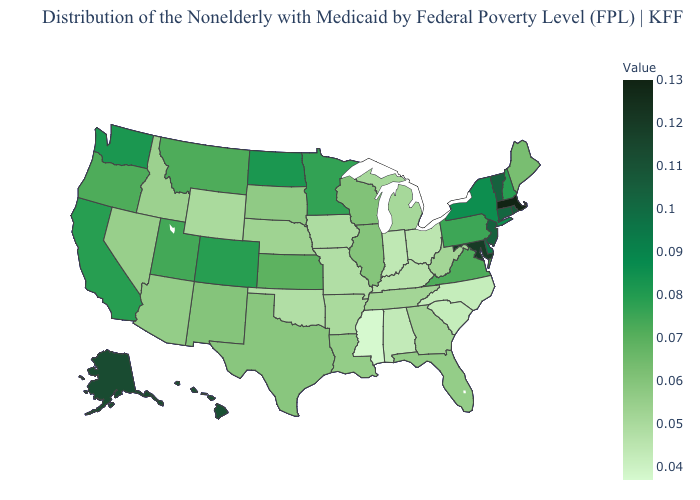Does Mississippi have the lowest value in the South?
Short answer required. Yes. Among the states that border Texas , does Oklahoma have the lowest value?
Answer briefly. Yes. Among the states that border Kentucky , which have the highest value?
Write a very short answer. Virginia. Which states hav the highest value in the MidWest?
Quick response, please. North Dakota. Which states have the highest value in the USA?
Give a very brief answer. Massachusetts. 